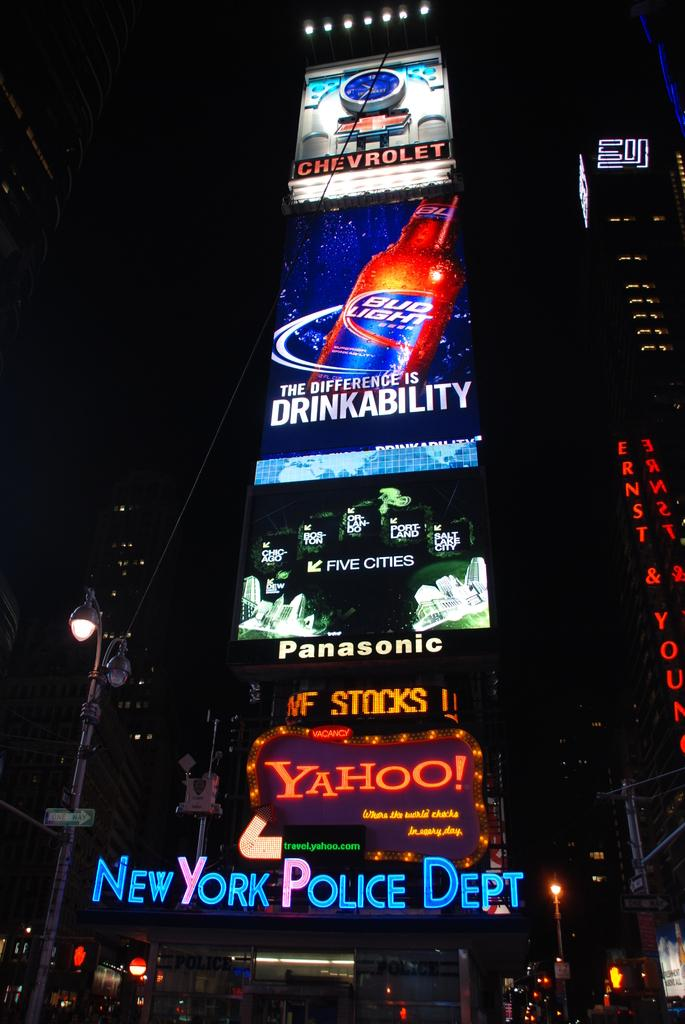<image>
Give a short and clear explanation of the subsequent image. a building that says 'new york police dept' on the bottom of it 